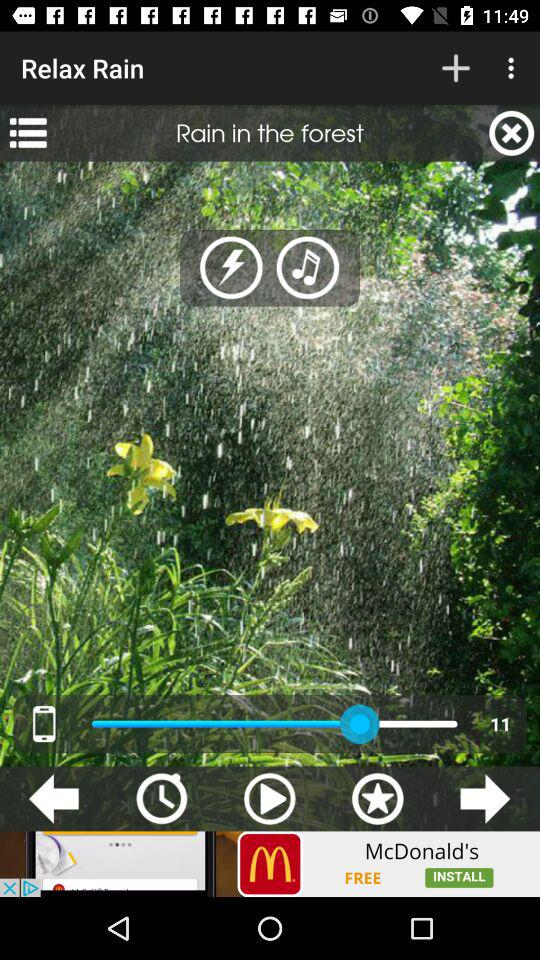What is the volume level? The volume level is 11. 